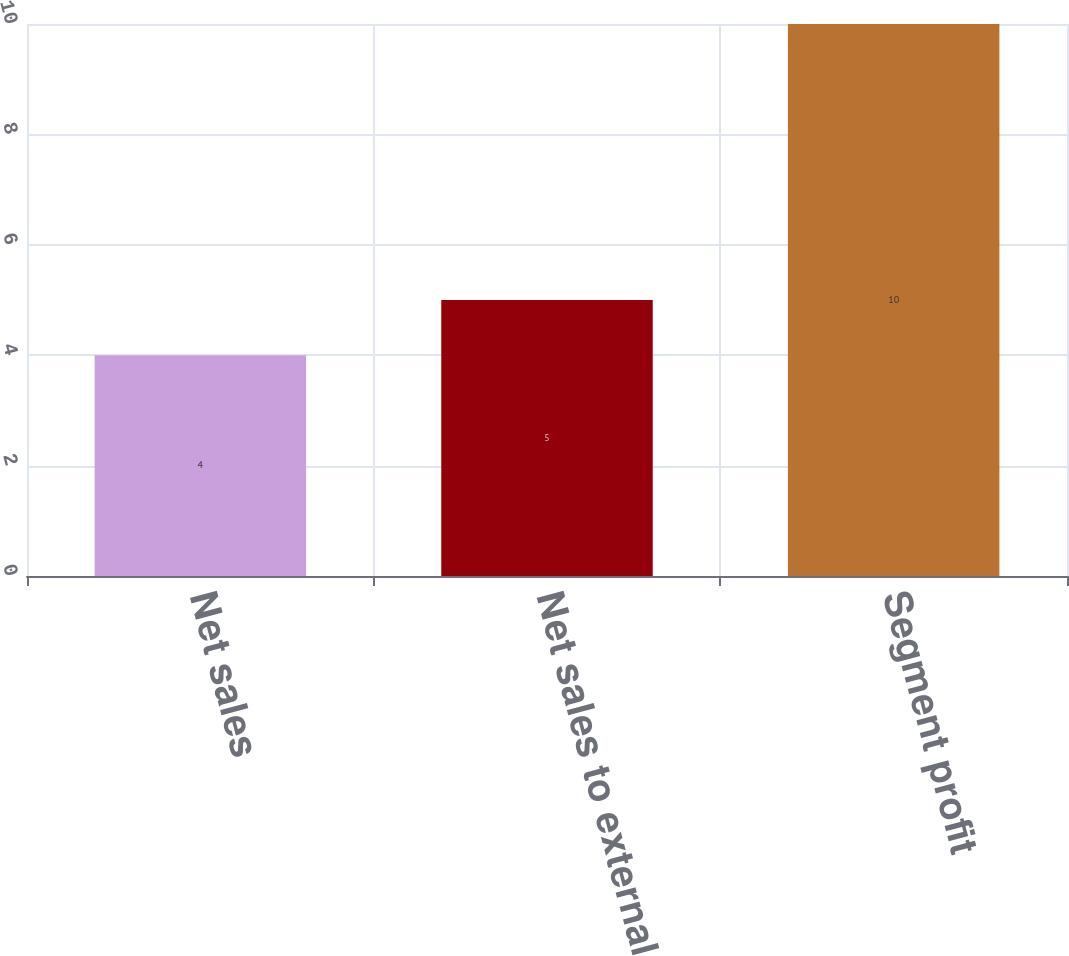Convert chart to OTSL. <chart><loc_0><loc_0><loc_500><loc_500><bar_chart><fcel>Net sales<fcel>Net sales to external<fcel>Segment profit<nl><fcel>4<fcel>5<fcel>10<nl></chart> 